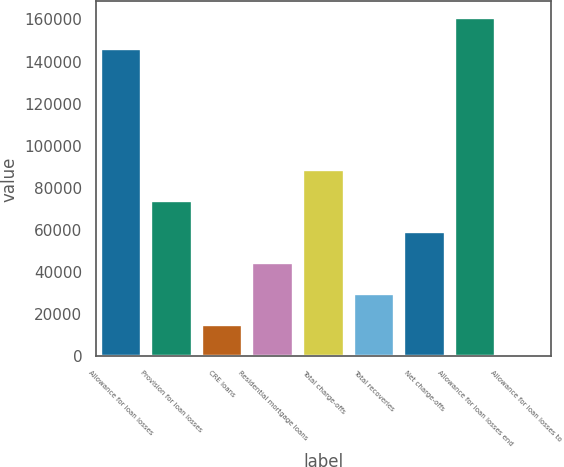<chart> <loc_0><loc_0><loc_500><loc_500><bar_chart><fcel>Allowance for loan losses<fcel>Provision for loan losses<fcel>CRE loans<fcel>Residential mortgage loans<fcel>Total charge-offs<fcel>Total recoveries<fcel>Net charge-offs<fcel>Allowance for loan losses end<fcel>Allowance for loan losses to<nl><fcel>145744<fcel>73771.4<fcel>14755.7<fcel>44263.6<fcel>88525.3<fcel>29509.7<fcel>59017.5<fcel>160498<fcel>1.81<nl></chart> 